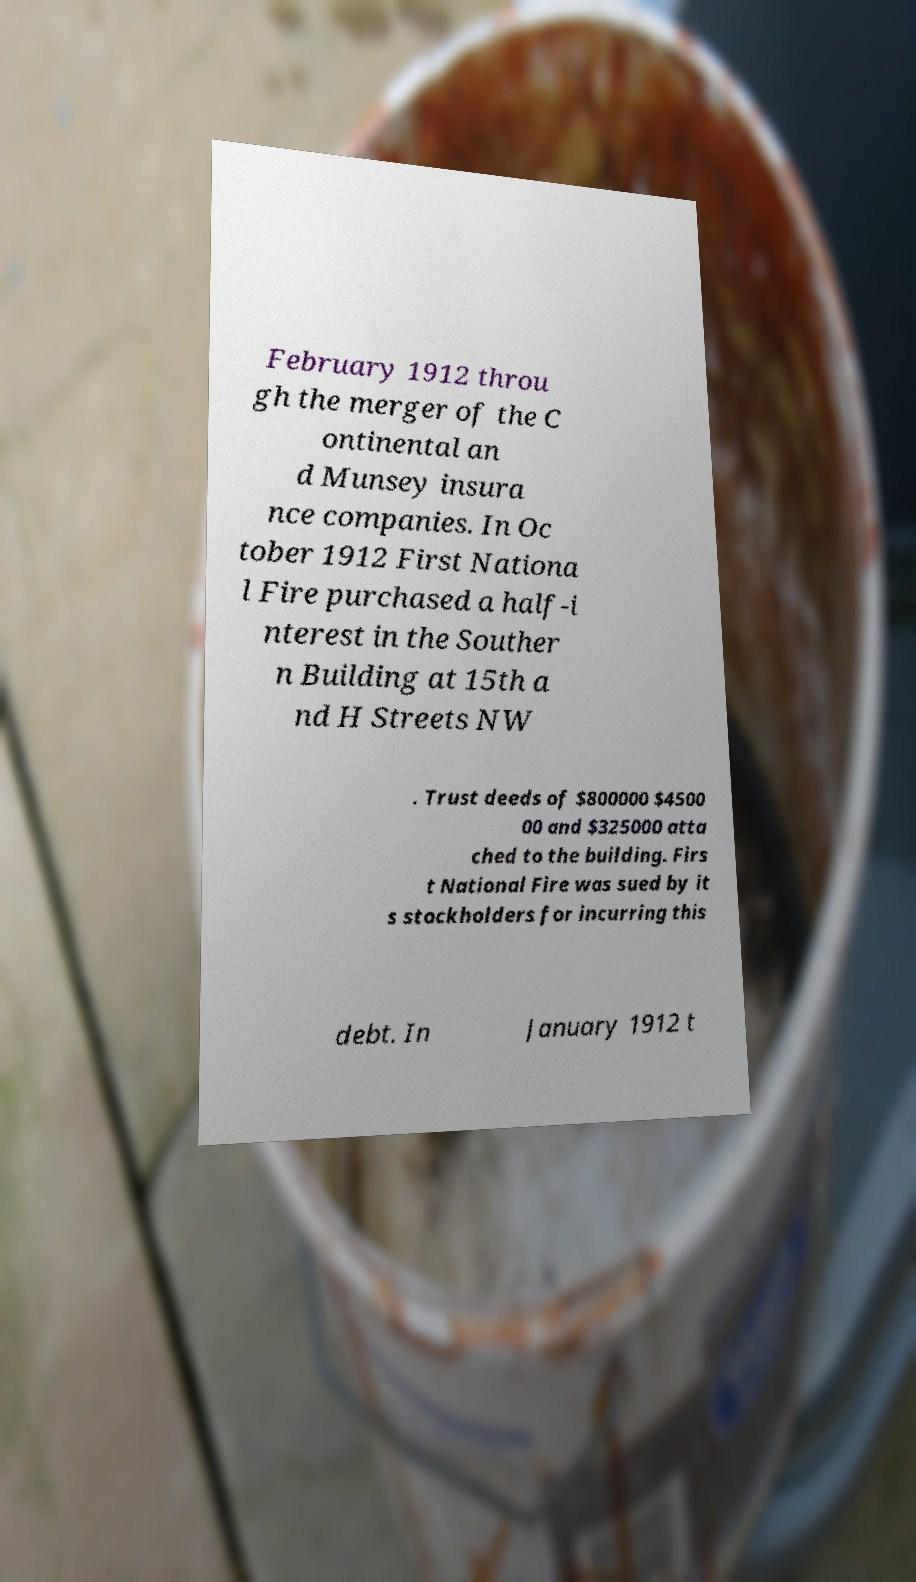Can you accurately transcribe the text from the provided image for me? February 1912 throu gh the merger of the C ontinental an d Munsey insura nce companies. In Oc tober 1912 First Nationa l Fire purchased a half-i nterest in the Souther n Building at 15th a nd H Streets NW . Trust deeds of $800000 $4500 00 and $325000 atta ched to the building. Firs t National Fire was sued by it s stockholders for incurring this debt. In January 1912 t 